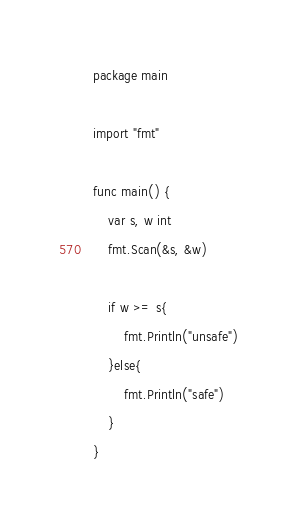Convert code to text. <code><loc_0><loc_0><loc_500><loc_500><_Go_>package main

import "fmt"

func main() {
	var s, w int
	fmt.Scan(&s, &w)

	if w >= s{
		fmt.Println("unsafe")
	}else{
		fmt.Println("safe")
	}
}
</code> 